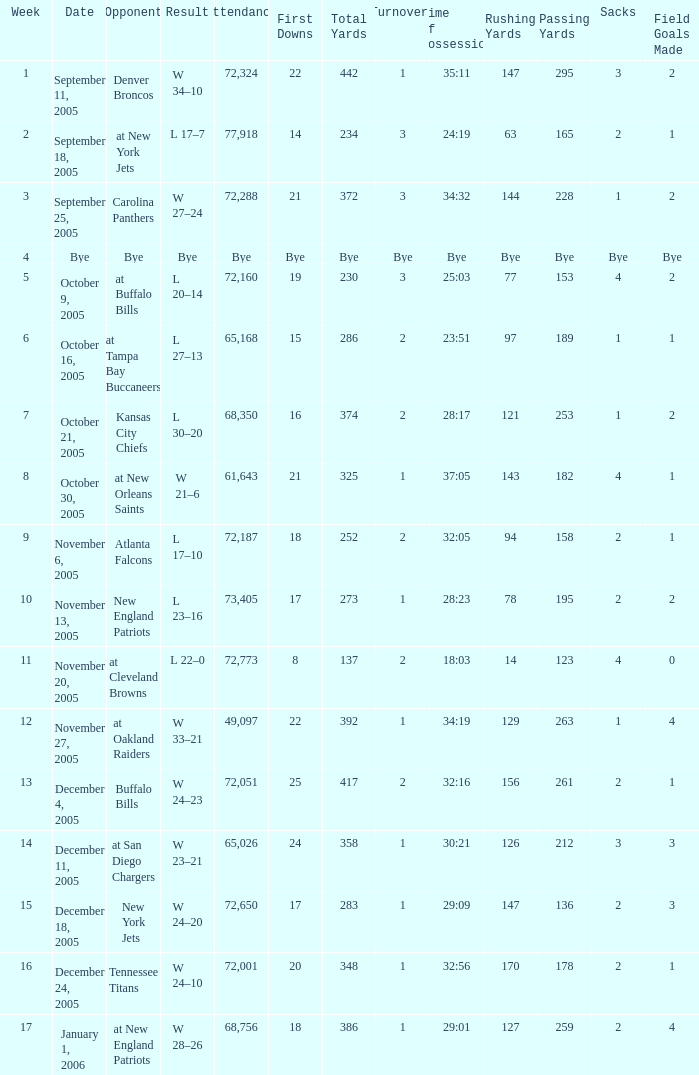What is the Week with a Date of Bye? 1.0. 